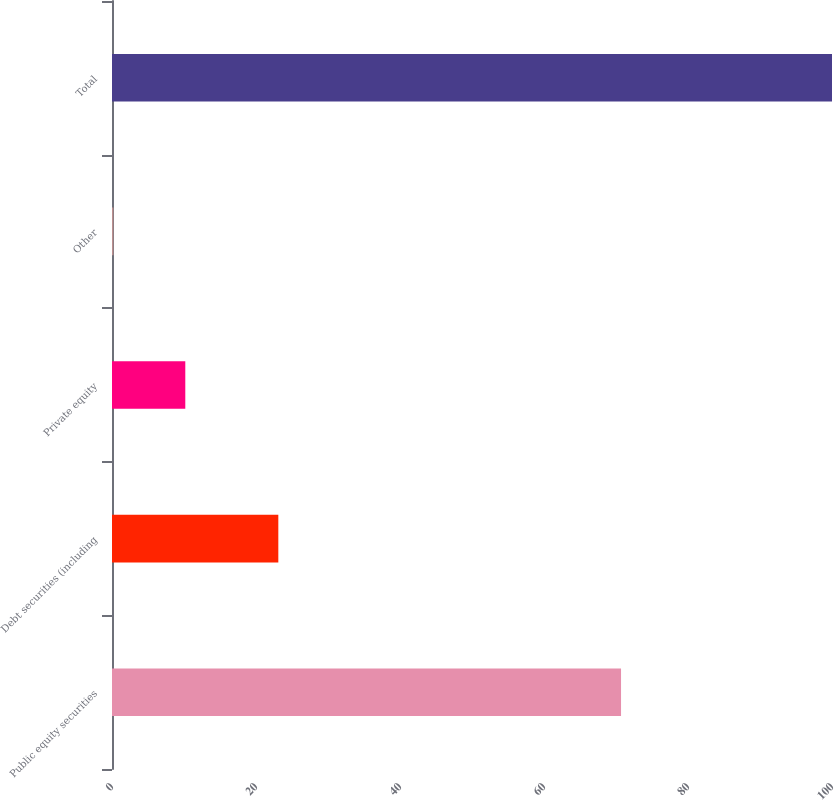Convert chart. <chart><loc_0><loc_0><loc_500><loc_500><bar_chart><fcel>Public equity securities<fcel>Debt securities (including<fcel>Private equity<fcel>Other<fcel>Total<nl><fcel>70.7<fcel>23.1<fcel>10.18<fcel>0.2<fcel>100<nl></chart> 